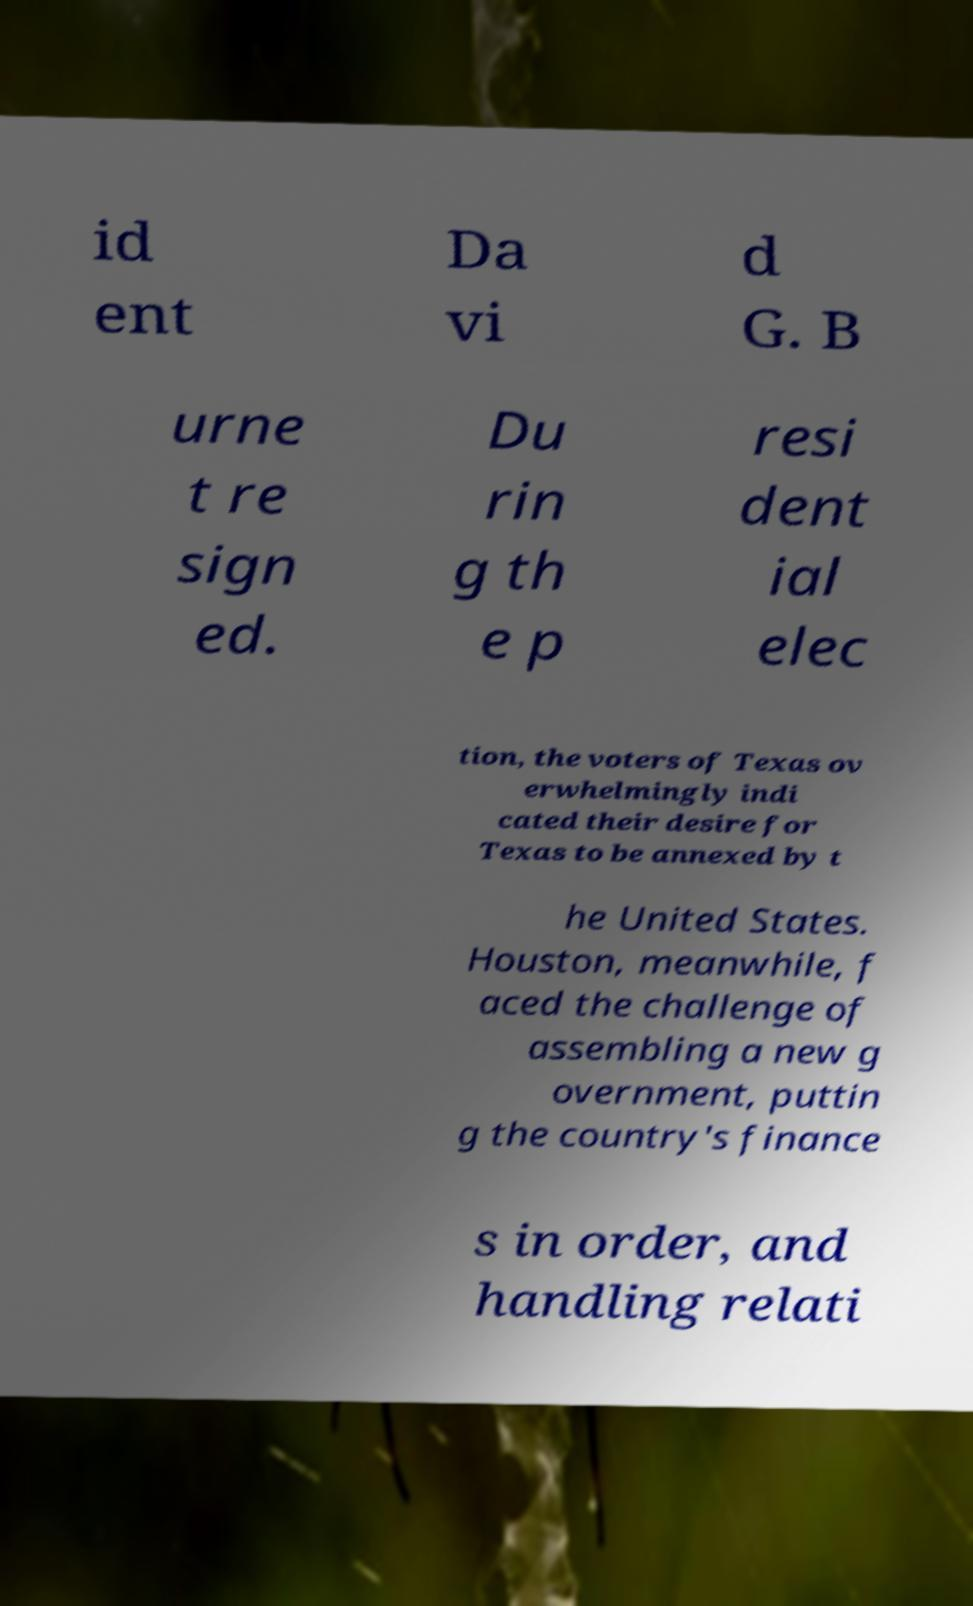Could you assist in decoding the text presented in this image and type it out clearly? id ent Da vi d G. B urne t re sign ed. Du rin g th e p resi dent ial elec tion, the voters of Texas ov erwhelmingly indi cated their desire for Texas to be annexed by t he United States. Houston, meanwhile, f aced the challenge of assembling a new g overnment, puttin g the country's finance s in order, and handling relati 